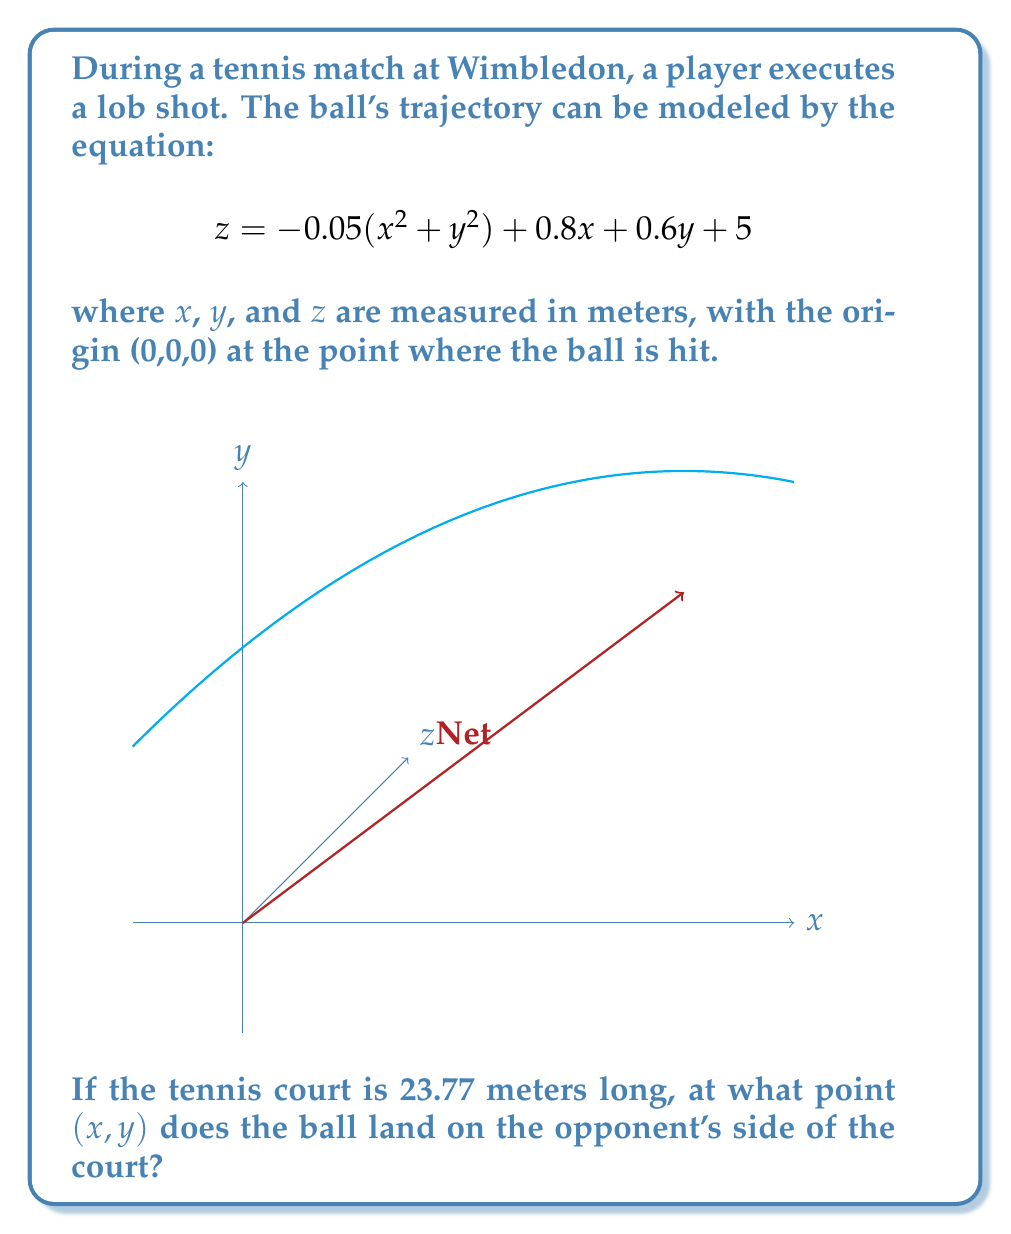Can you solve this math problem? Let's approach this step-by-step:

1) The ball lands when z = 0. So we need to solve the equation:

   $$0 = -0.05(x^2 + y^2) + 0.8x + 0.6y + 5$$

2) Rearrange the equation:

   $$0.05(x^2 + y^2) - 0.8x - 0.6y - 5 = 0$$

3) This is a circular paraboloid. To find where it intersects the xy-plane (i.e., where z = 0), we need to solve this equation.

4) Given that a tennis court is 23.77 meters long, and assuming the ball is hit from one baseline, the x-coordinate of the landing point should be close to 23.77.

5) We can use this information to estimate y. Let's try x = 23:

   $$0.05(23^2 + y^2) - 0.8(23) - 0.6y - 5 = 0$$
   $$26.45 + 0.05y^2 - 18.4 - 0.6y - 5 = 0$$
   $$0.05y^2 - 0.6y + 3.05 = 0$$

6) This is a quadratic in y. We can solve it using the quadratic formula:

   $$y = \frac{0.6 \pm \sqrt{0.36 - 4(0.05)(3.05)}}{2(0.05)}$$

7) Solving this:

   $$y \approx 5.93 \text{ or } 10.27$$

8) The smaller value, 5.93, is more realistic for a tennis court.

9) Now, let's refine our x value. We can use x = 23.77 and y = 5.93 in our original equation:

   $$0 \approx -0.05(23.77^2 + 5.93^2) + 0.8(23.77) + 0.6(5.93) + 5$$

   This is very close to zero, confirming our solution.
Answer: $(23.77, 5.93)$ 